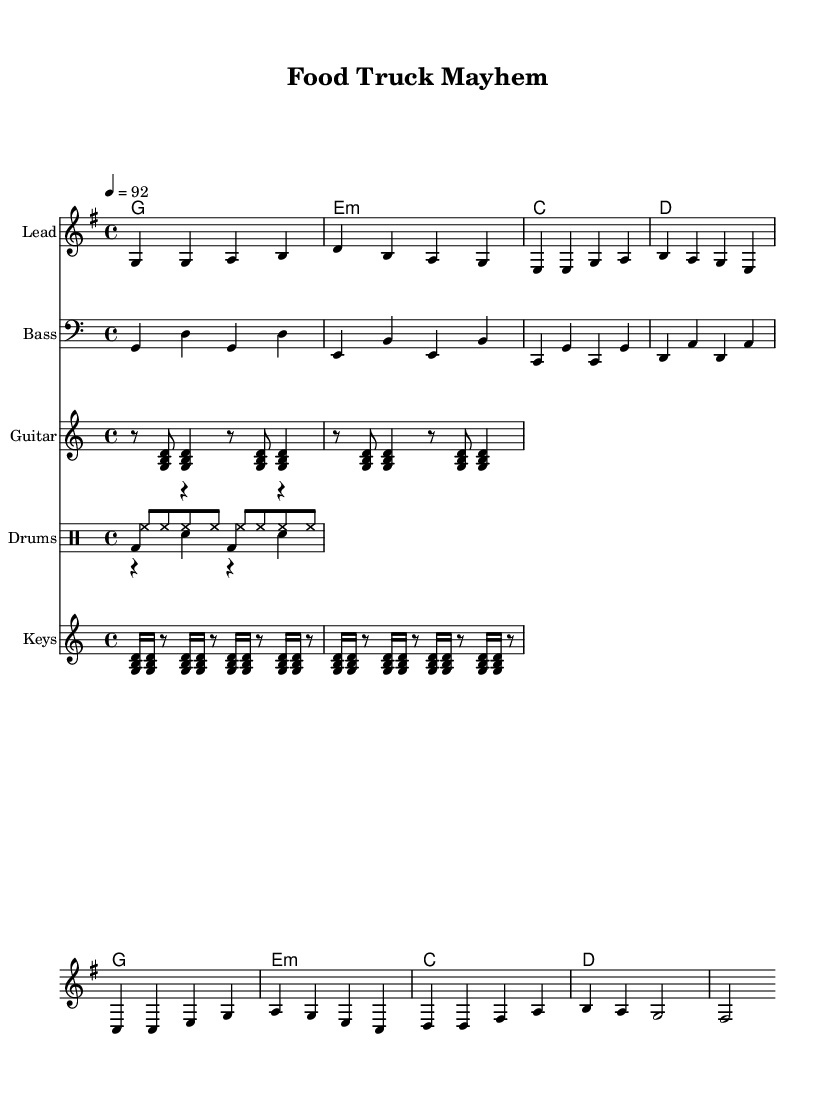What is the key signature of this music? The key signature indicated at the beginning of the score is one sharp, which corresponds to the key of G major.
Answer: G major What is the time signature of this music? The time signature is displayed right after the key signature and shows 4 over 4, meaning there are four beats in each measure and a quarter note gets one beat.
Answer: 4/4 What is the tempo indicated in the score? The tempo marking, placed above the staff, indicates that the piece should be played at a speed of 92 beats per minute.
Answer: 92 How many measures are in the melody section? The melody consists of 8 measures, which can be counted by following the measures throughout the melodic line presented.
Answer: 8 Which instrument plays the bass line? The bass line is notated on the staff labeled "Bass," indicating that it is performed by the bass instrument.
Answer: Bass What is the main theme of the lyrics? The lyrics express a humorous situation involving food truck adventures, including challenges related to the menu and requests for junk food, indicating a light-hearted approach.
Answer: Food truck adventures What type of chords are primarily used in the harmonies? The harmonies are based on major and minor chords, specifically G major, E minor, C major, and D major, which are common in reggae music.
Answer: Major and minor chords 